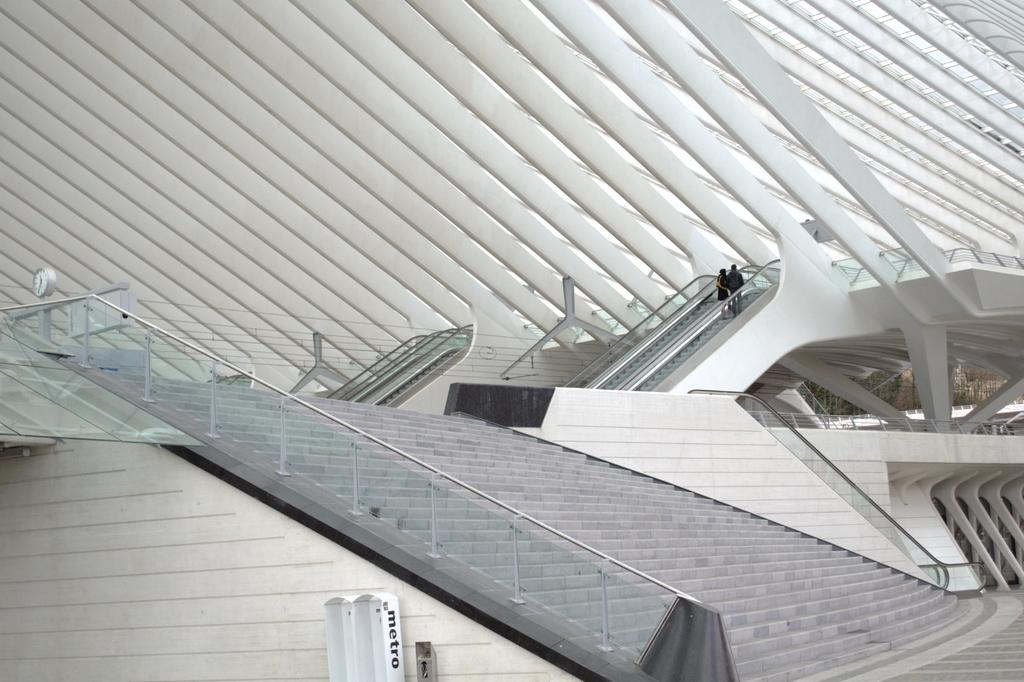What type of architectural feature can be seen in the image? There are steps with glass railings in the image. What kind of structure is depicted in the image? There is a building with pillars in the image. Are there any transportation features inside the building? Yes, there are escalators in the building. How many people are present in the image? There are two persons in the image. What type of cactus can be seen growing on the escalators in the image? There is no cactus present in the image, and the escalators are not a suitable environment for plant growth. 